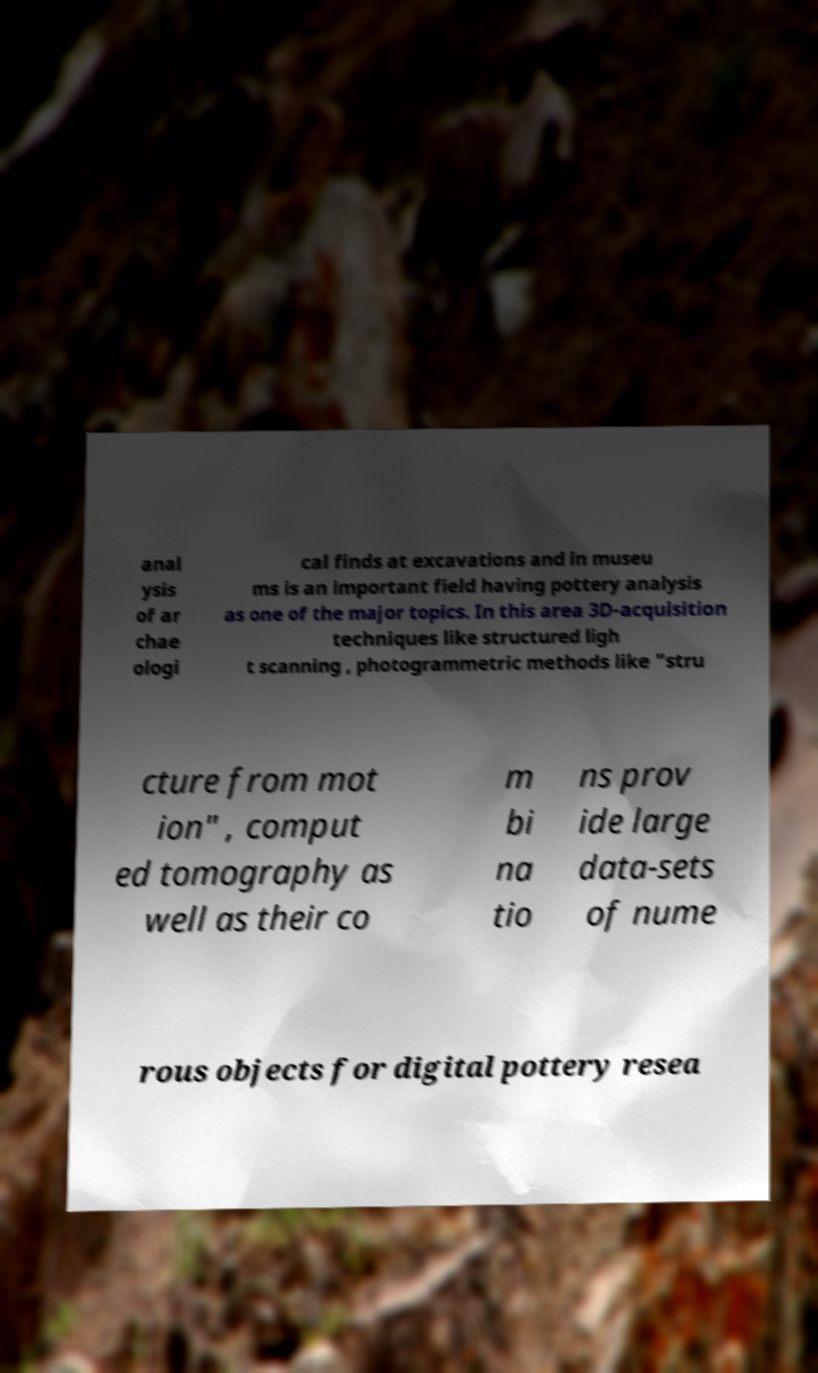I need the written content from this picture converted into text. Can you do that? anal ysis of ar chae ologi cal finds at excavations and in museu ms is an important field having pottery analysis as one of the major topics. In this area 3D-acquisition techniques like structured ligh t scanning , photogrammetric methods like "stru cture from mot ion" , comput ed tomography as well as their co m bi na tio ns prov ide large data-sets of nume rous objects for digital pottery resea 